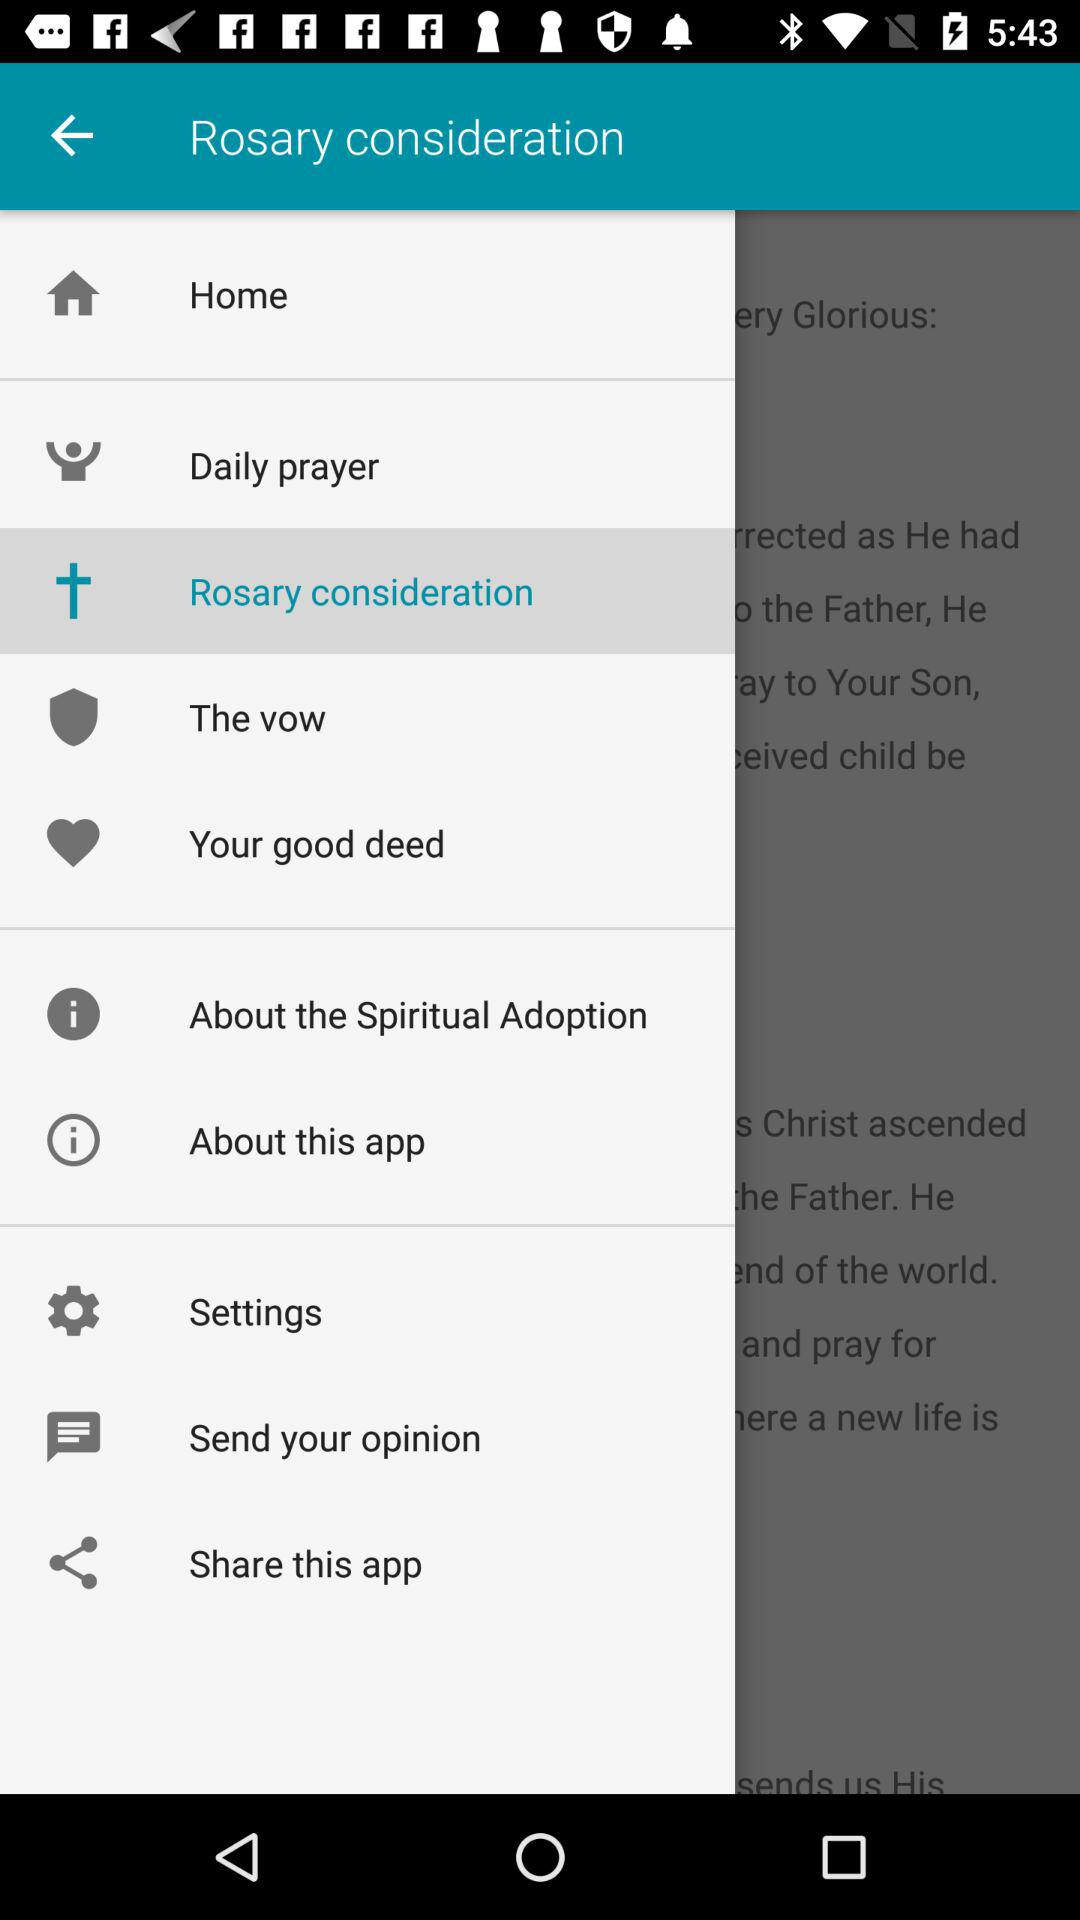Which tab is selected? The selected tab is "Rosary consideration". 